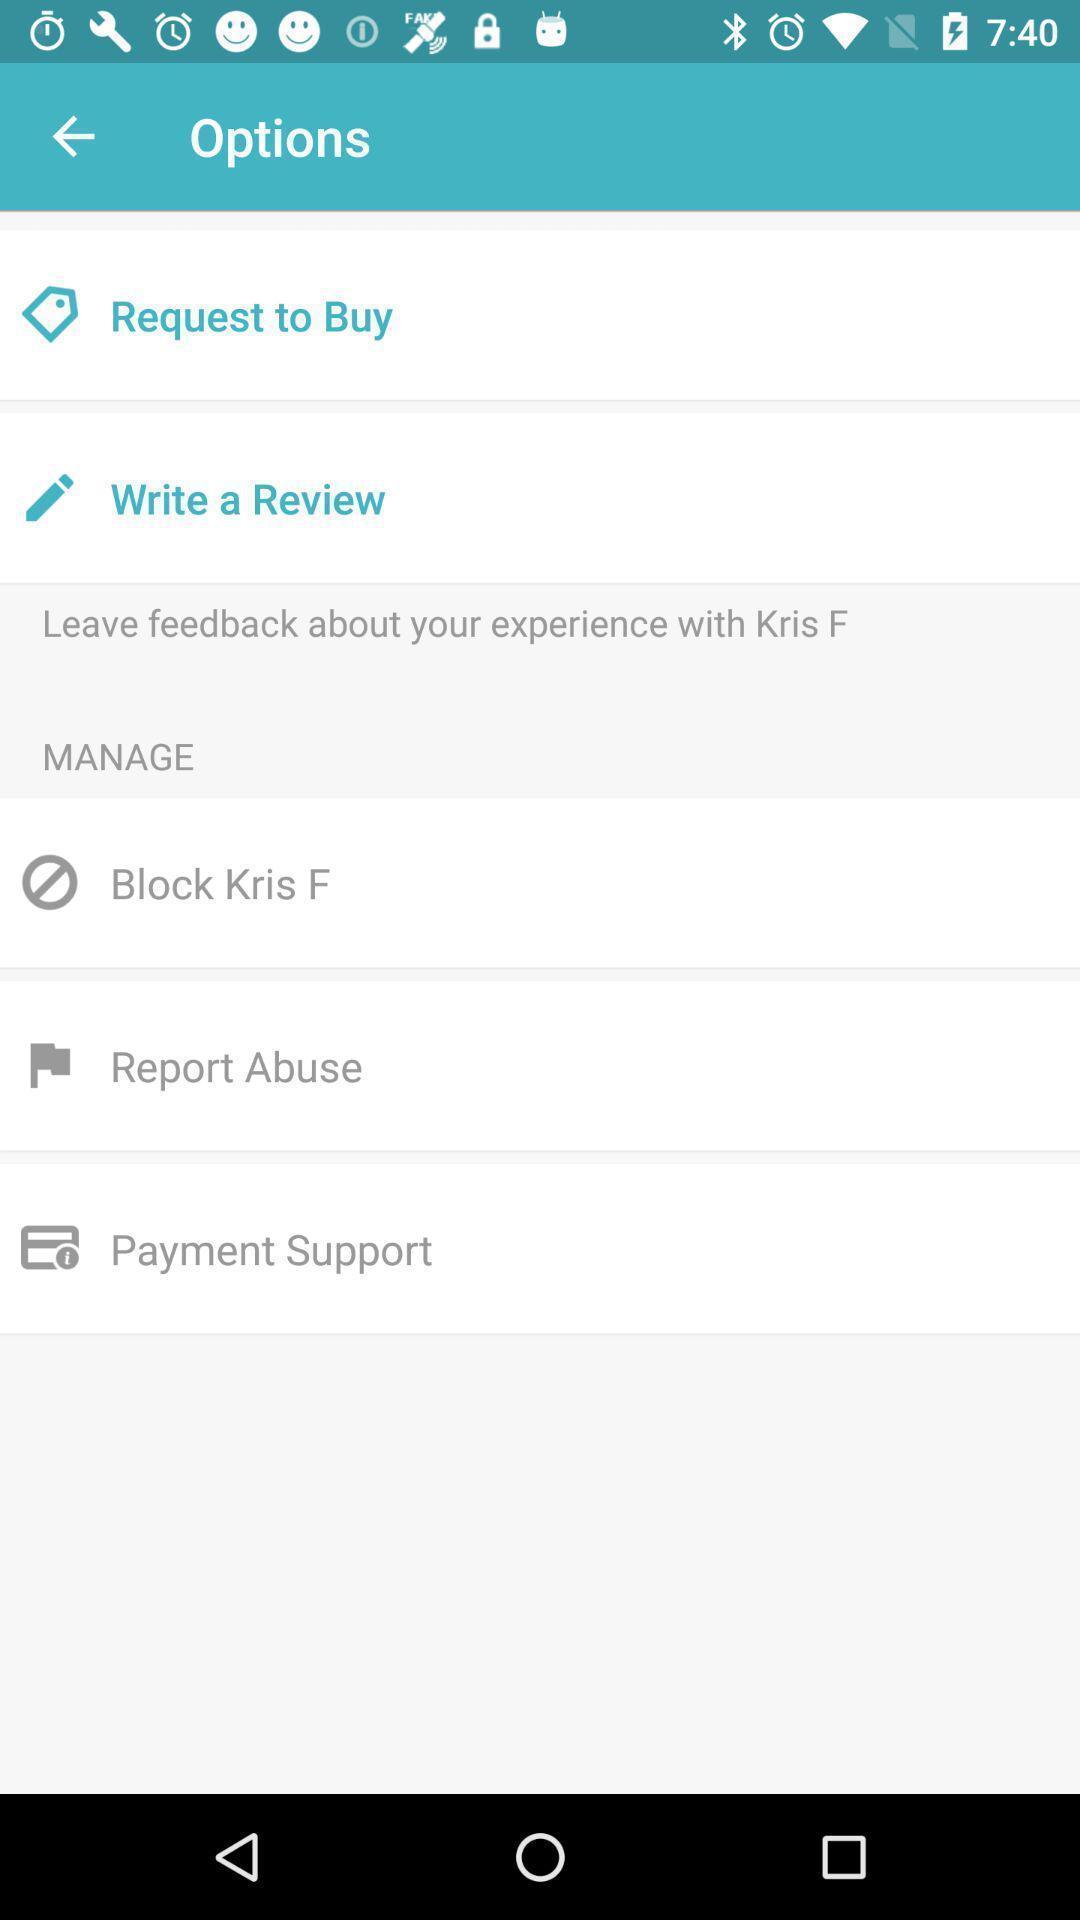Give me a summary of this screen capture. Page displaying with list of different options in shopping application. 